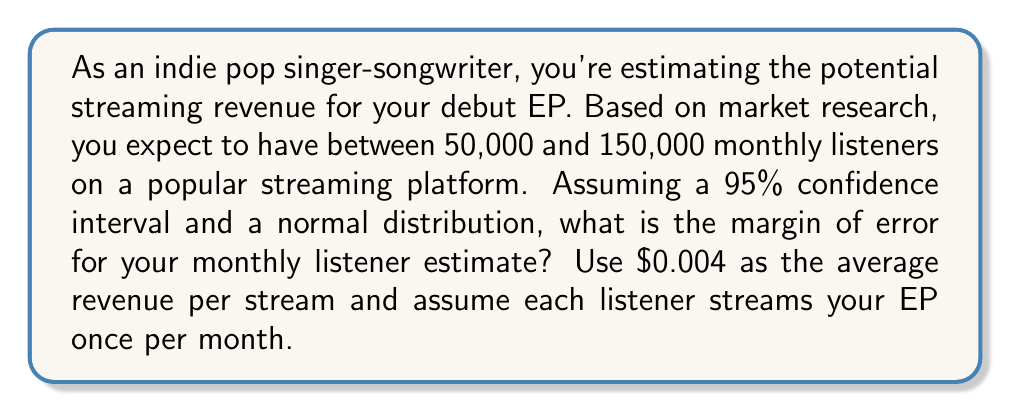Give your solution to this math problem. To solve this problem, we'll follow these steps:

1) First, we need to find the mean of our estimated range:
   $\mu = \frac{50,000 + 150,000}{2} = 100,000$ listeners

2) The range (150,000 - 50,000 = 100,000) represents approximately 4 standard deviations in a normal distribution. So, one standard deviation is:
   $\sigma = \frac{100,000}{4} = 25,000$ listeners

3) For a 95% confidence interval, we use a z-score of 1.96.

4) The margin of error formula is:
   $\text{Margin of Error} = z \cdot \frac{\sigma}{\sqrt{n}}$

   Where $z$ is the z-score, $\sigma$ is the standard deviation, and $n$ is the sample size.

5) In this case, we don't have a sample size, so we'll use the formula without $\sqrt{n}$:
   $\text{Margin of Error} = z \cdot \sigma$

6) Plugging in our values:
   $\text{Margin of Error} = 1.96 \cdot 25,000 = 49,000$ listeners

7) To convert this to potential revenue, we multiply by $0.004 (revenue per stream):
   $49,000 \cdot 0.004 = $196$

Therefore, the margin of error for your monthly streaming revenue estimate is $196.
Answer: $196 